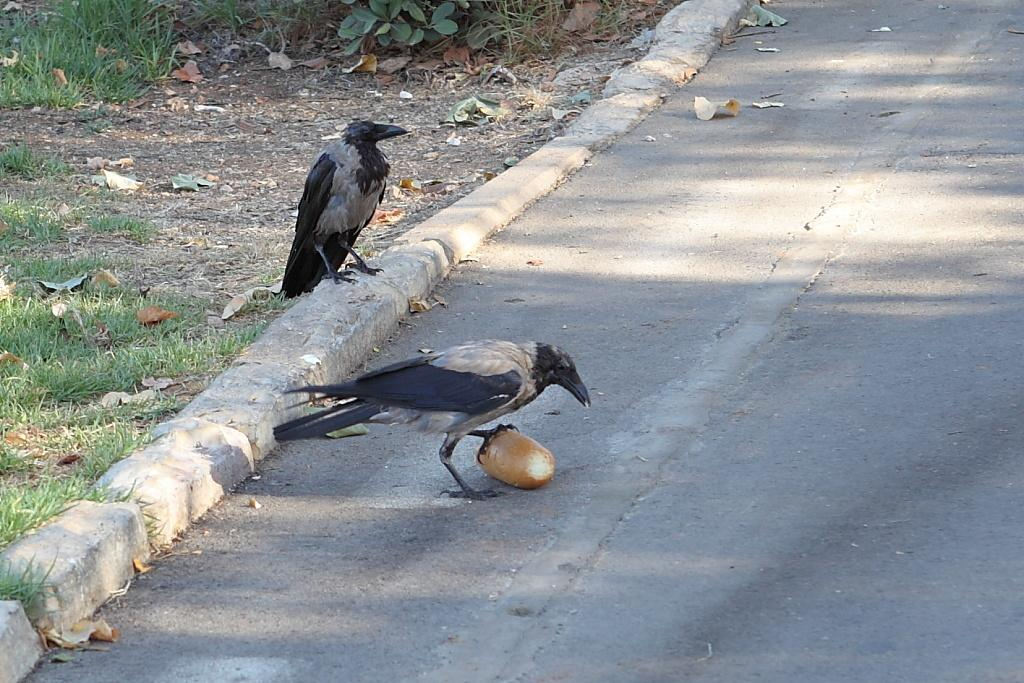How many birds can be seen in the image? There are two birds in the image. What type of food item is present in the image? The food item in the image is not specified, but it is mentioned that there is one. What type of vegetation is present in the image? Grass and plants are visible in the image. Where are the dried leaves located in the image? The dried leaves are in the top left corner of the image. What type of clam is being served with the fork in the image? There is no clam or fork present in the image. How does the pump contribute to the image's overall aesthetic? There is no pump present in the image, so it cannot contribute to the image's aesthetic. 